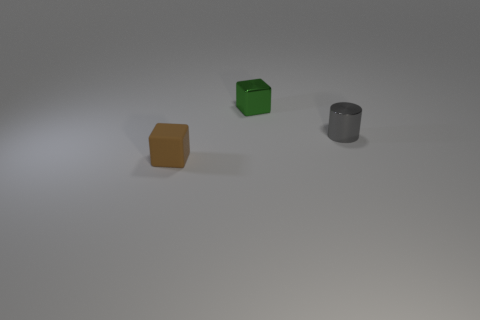Add 1 metal cylinders. How many objects exist? 4 Subtract all blocks. How many objects are left? 1 Subtract all tiny green objects. Subtract all brown blocks. How many objects are left? 1 Add 2 small brown rubber blocks. How many small brown rubber blocks are left? 3 Add 3 green cubes. How many green cubes exist? 4 Subtract 0 blue spheres. How many objects are left? 3 